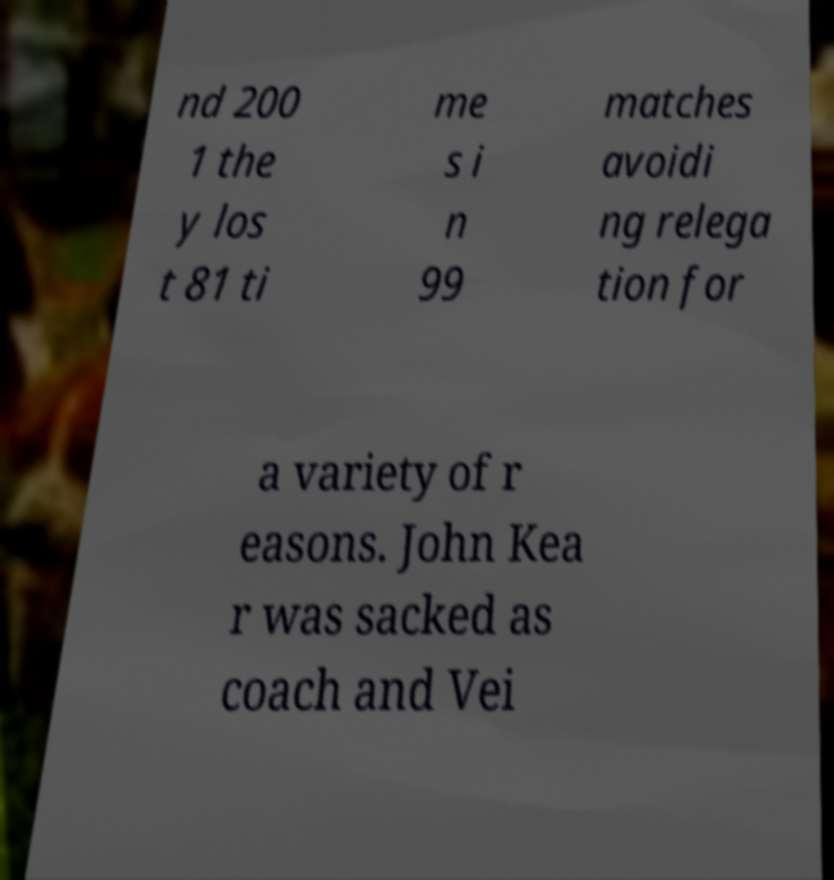Could you assist in decoding the text presented in this image and type it out clearly? nd 200 1 the y los t 81 ti me s i n 99 matches avoidi ng relega tion for a variety of r easons. John Kea r was sacked as coach and Vei 